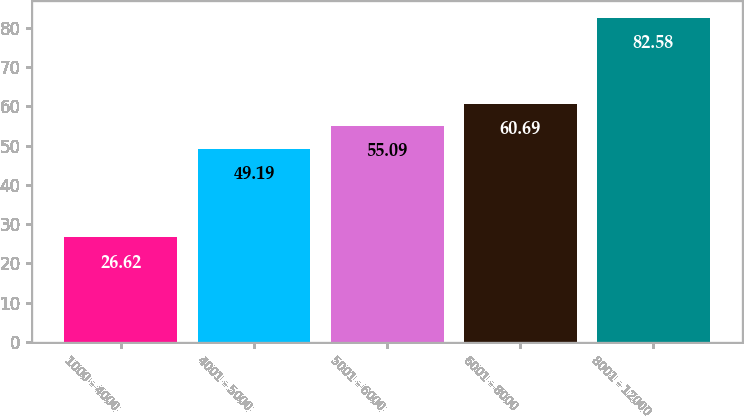Convert chart to OTSL. <chart><loc_0><loc_0><loc_500><loc_500><bar_chart><fcel>1000 - 4000<fcel>4001 - 5000<fcel>5001 - 6000<fcel>6001 - 8000<fcel>8001 - 12000<nl><fcel>26.62<fcel>49.19<fcel>55.09<fcel>60.69<fcel>82.58<nl></chart> 